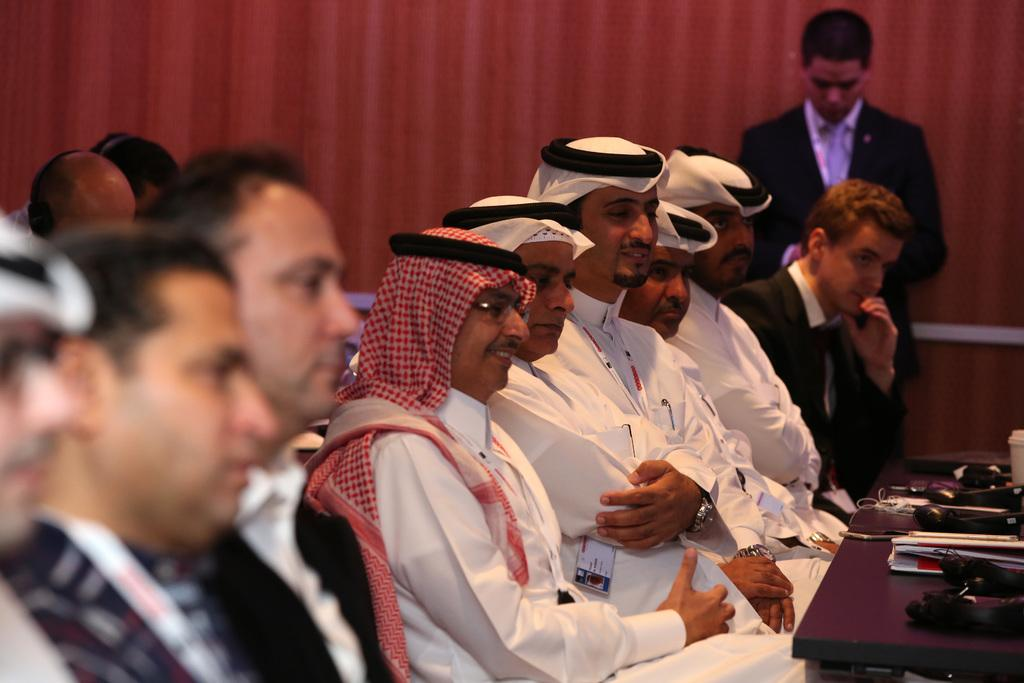What type of people are present in the image? There are many Arab men in the image, along with other men. What are the men doing in the image? The men are sitting in front of a table. Can you describe the setting of the image? The setting appears to be a meeting room. What type of oranges are being discussed in the meeting? There is no mention of oranges or any discussion in the image. What news is being shared among the men in the image? There is no indication of news being shared or discussed in the image. 